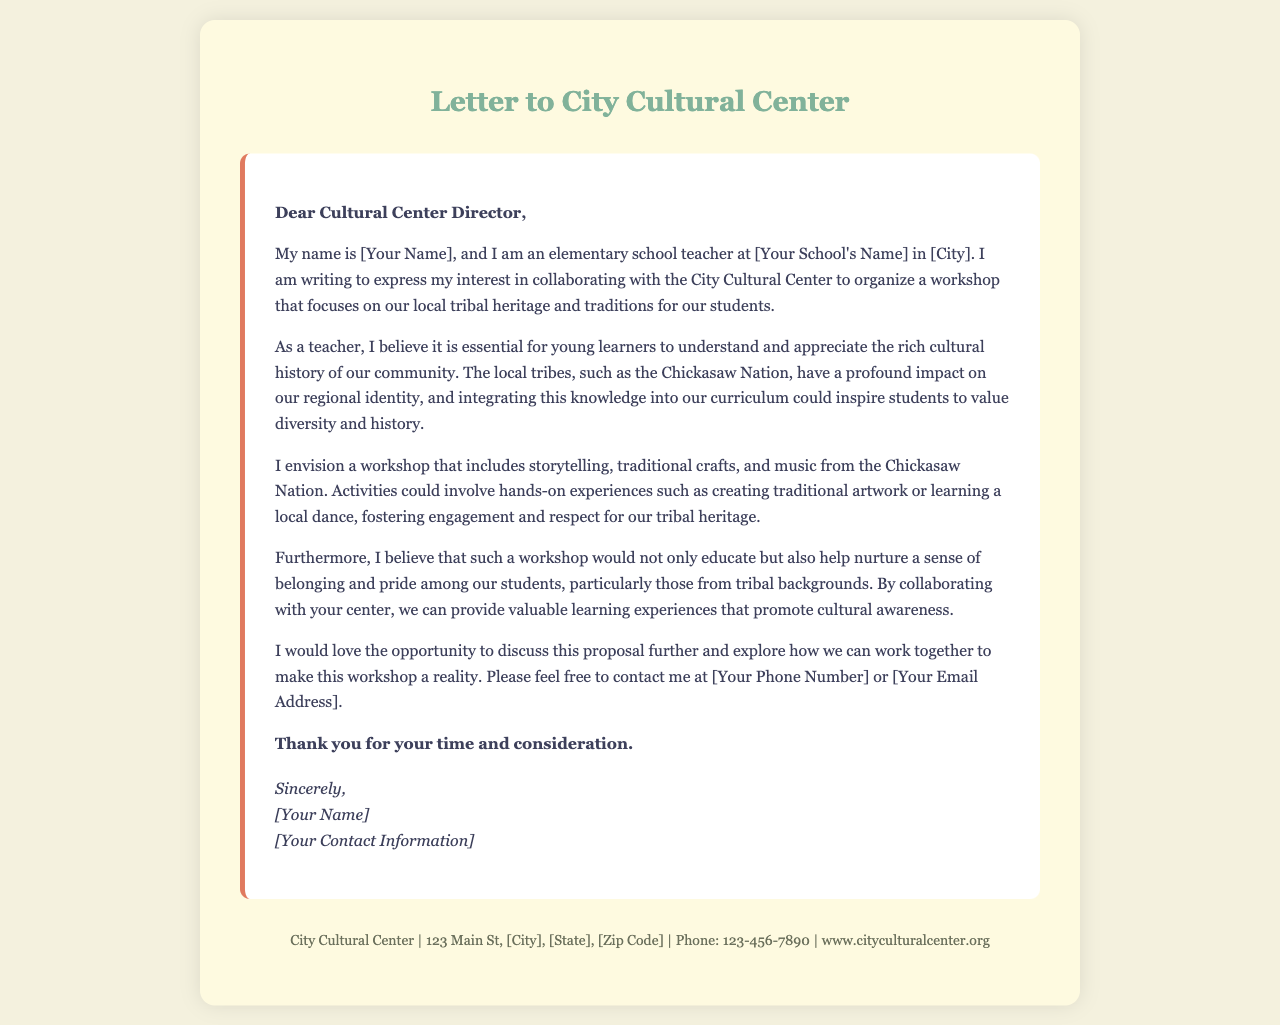What is the purpose of the letter? The letter expresses interest in organizing a workshop that focuses on tribal heritage and traditions for students.
Answer: Organizing a workshop Who is the letter addressed to? The letter is addressed to the Cultural Center Director of the City Cultural Center.
Answer: Cultural Center Director What local tribe is mentioned in the letter? The letter specifically mentions the Chickasaw Nation as a local tribe.
Answer: Chickasaw Nation What activities are proposed for the workshop? The proposed activities include storytelling, traditional crafts, and music from the Chickasaw Nation.
Answer: Storytelling, traditional crafts, music What does the writer believe the workshop will nurture among students? The writer believes the workshop will nurture a sense of belonging and pride among students.
Answer: Belonging and pride 